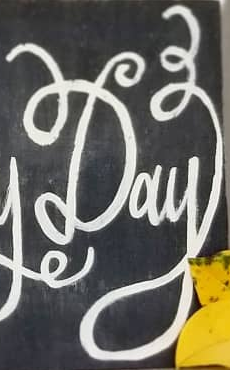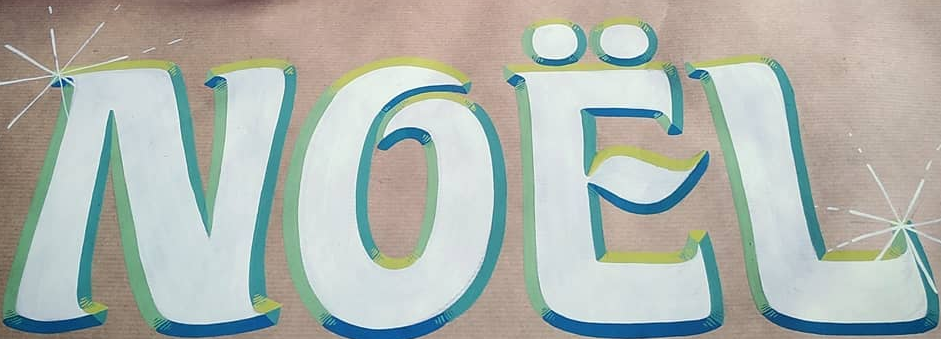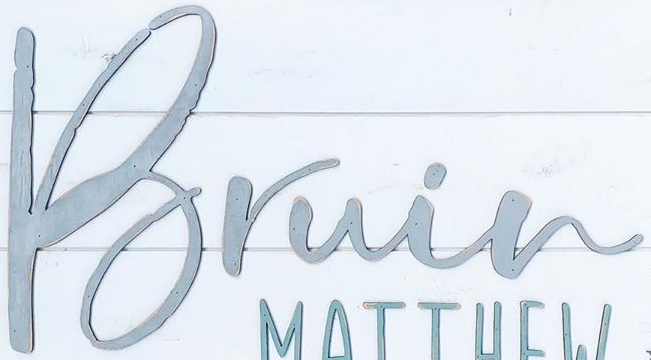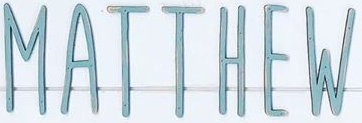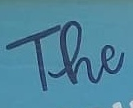Read the text content from these images in order, separated by a semicolon. Day; NOËL; Bruin; MATTHEW; The 